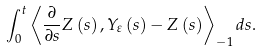Convert formula to latex. <formula><loc_0><loc_0><loc_500><loc_500>\int _ { 0 } ^ { t } \left \langle \frac { \partial } { \partial s } Z \left ( s \right ) , Y _ { \varepsilon } \left ( s \right ) - Z \left ( s \right ) \right \rangle _ { - 1 } d s .</formula> 